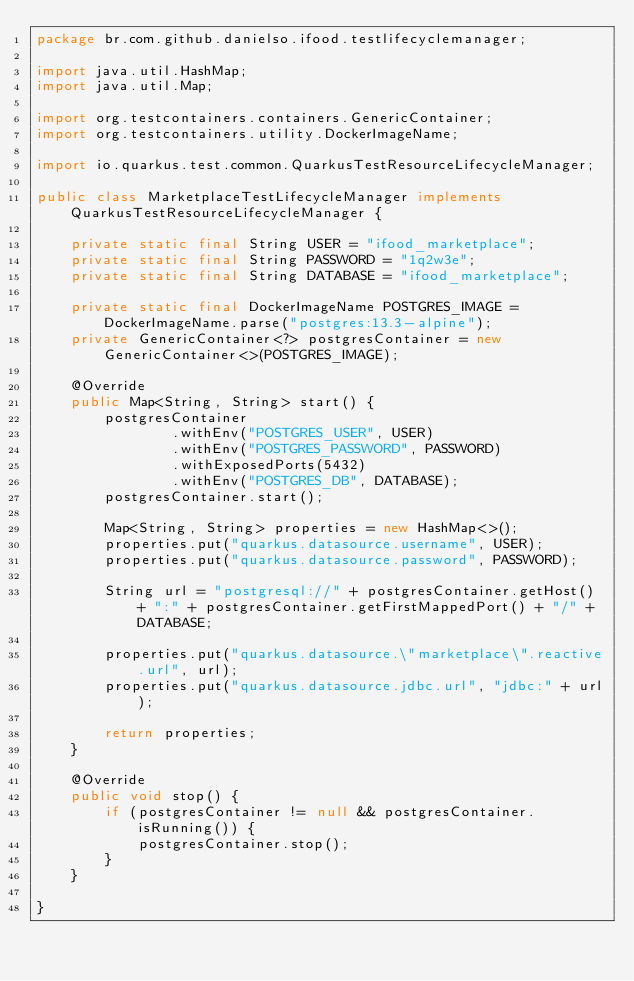Convert code to text. <code><loc_0><loc_0><loc_500><loc_500><_Java_>package br.com.github.danielso.ifood.testlifecyclemanager;

import java.util.HashMap;
import java.util.Map;

import org.testcontainers.containers.GenericContainer;
import org.testcontainers.utility.DockerImageName;

import io.quarkus.test.common.QuarkusTestResourceLifecycleManager;

public class MarketplaceTestLifecycleManager implements QuarkusTestResourceLifecycleManager {

	private static final String USER = "ifood_marketplace";
	private static final String PASSWORD = "1q2w3e";
	private static final String DATABASE = "ifood_marketplace";
	
	private static final DockerImageName POSTGRES_IMAGE = DockerImageName.parse("postgres:13.3-alpine");
    private GenericContainer<?> postgresContainer = new GenericContainer<>(POSTGRES_IMAGE);

	@Override
	public Map<String, String> start() {
		postgresContainer
		        .withEnv("POSTGRES_USER", USER)
				.withEnv("POSTGRES_PASSWORD", PASSWORD)
				.withExposedPorts(5432)
				.withEnv("POSTGRES_DB", DATABASE);
		postgresContainer.start();

		Map<String, String> properties = new HashMap<>();
		properties.put("quarkus.datasource.username", USER);
		properties.put("quarkus.datasource.password", PASSWORD);
		
		String url = "postgresql://" + postgresContainer.getHost() + ":" + postgresContainer.getFirstMappedPort() + "/" + DATABASE;
		
		properties.put("quarkus.datasource.\"marketplace\".reactive.url", url);
		properties.put("quarkus.datasource.jdbc.url", "jdbc:" + url);

		return properties;
	}

	@Override
	public void stop() {
		if (postgresContainer != null && postgresContainer.isRunning()) {
			postgresContainer.stop();
		}
	}

}
</code> 